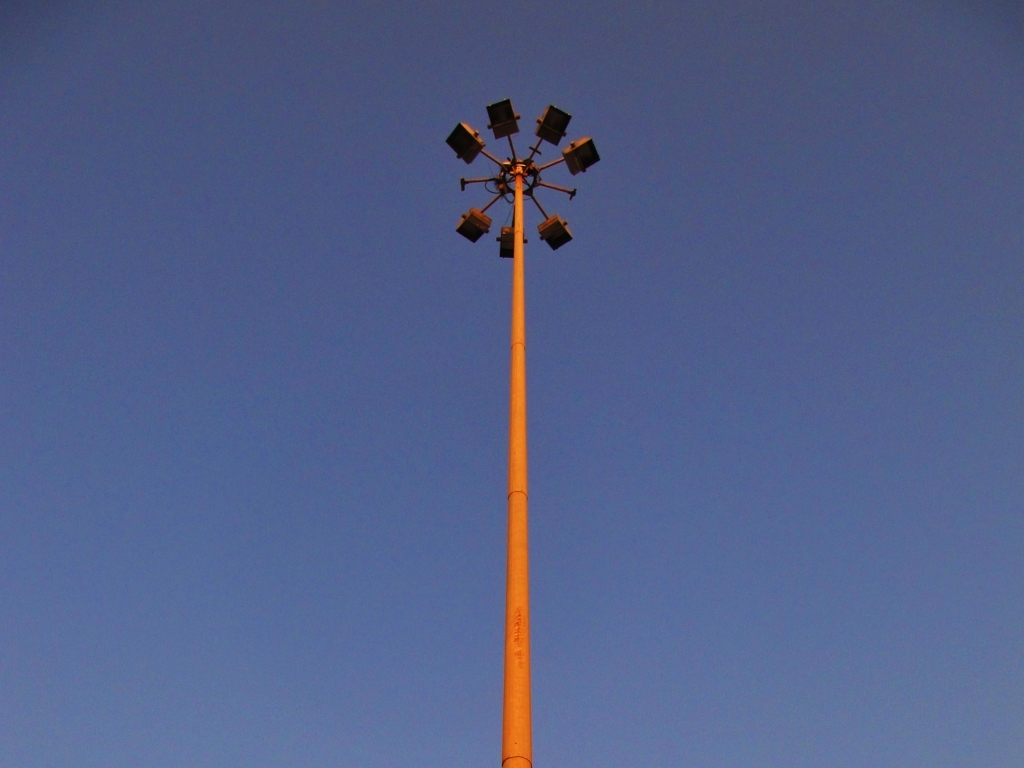What might these structures be used for? These are floodlights typically used to illuminate large areas, such as parking lots, sports fields, or event spaces, providing visibility and security during the night. How can you tell they are floodlights? The design of the fixtures, including their size, shape, and the way they are clustered and directed outward, is characteristic of floodlights designed to cast a wide, bright light over a large area. 